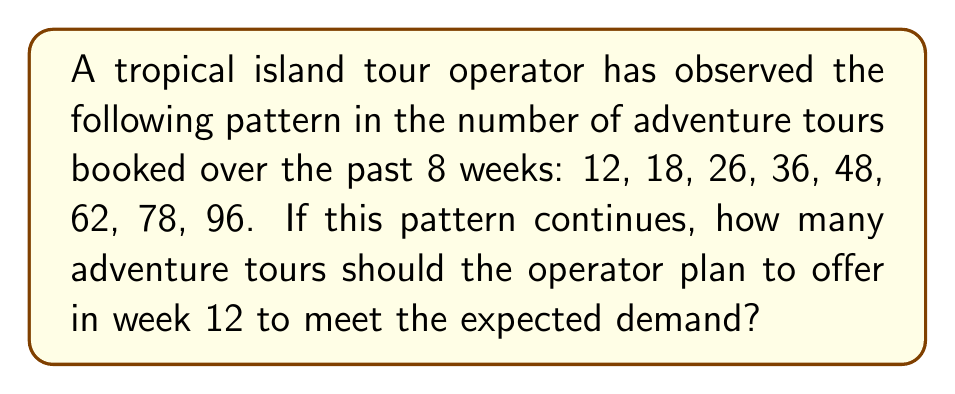Solve this math problem. To solve this problem, we need to identify the pattern in the sequence and extend it to week 12. Let's approach this step-by-step:

1. Calculate the differences between consecutive terms:
   $18 - 12 = 6$
   $26 - 18 = 8$
   $36 - 26 = 10$
   $48 - 36 = 12$
   $62 - 48 = 14$
   $78 - 62 = 16$
   $96 - 78 = 18$

2. Notice that the differences form an arithmetic sequence: 6, 8, 10, 12, 14, 16, 18
   The common difference of this sequence is 2.

3. We can express the nth term of the original sequence as:
   $a_n = a_1 + \frac{n(n-1)}{2} \cdot 2$
   Where $a_1 = 12$ (the first term) and $n$ is the week number.

4. Simplify the equation:
   $a_n = 12 + n(n-1)$

5. To find the number of tours for week 12, substitute $n = 12$:
   $a_{12} = 12 + 12(12-1)$
   $a_{12} = 12 + 12 \cdot 11$
   $a_{12} = 12 + 132$
   $a_{12} = 144$

Therefore, the tour operator should plan to offer 144 adventure tours in week 12 to meet the expected demand based on the observed pattern.
Answer: 144 tours 